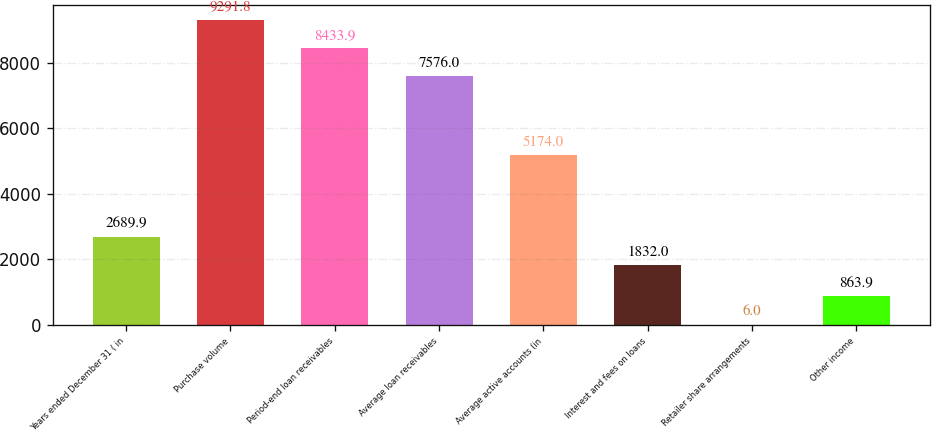Convert chart. <chart><loc_0><loc_0><loc_500><loc_500><bar_chart><fcel>Years ended December 31 ( in<fcel>Purchase volume<fcel>Period-end loan receivables<fcel>Average loan receivables<fcel>Average active accounts (in<fcel>Interest and fees on loans<fcel>Retailer share arrangements<fcel>Other income<nl><fcel>2689.9<fcel>9291.8<fcel>8433.9<fcel>7576<fcel>5174<fcel>1832<fcel>6<fcel>863.9<nl></chart> 